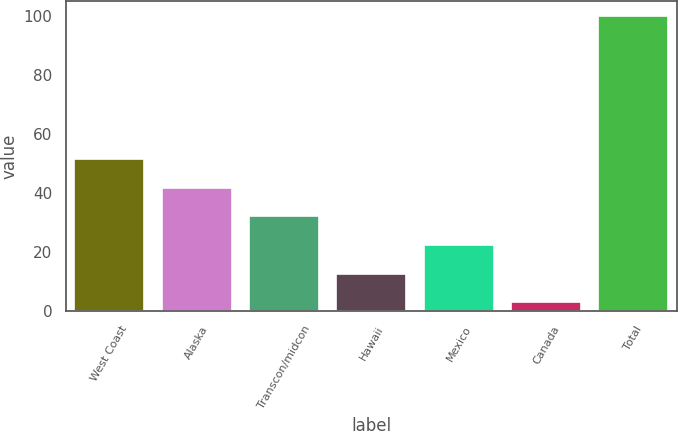Convert chart. <chart><loc_0><loc_0><loc_500><loc_500><bar_chart><fcel>West Coast<fcel>Alaska<fcel>Transcon/midcon<fcel>Hawaii<fcel>Mexico<fcel>Canada<fcel>Total<nl><fcel>51.5<fcel>41.8<fcel>32.1<fcel>12.7<fcel>22.4<fcel>3<fcel>100<nl></chart> 